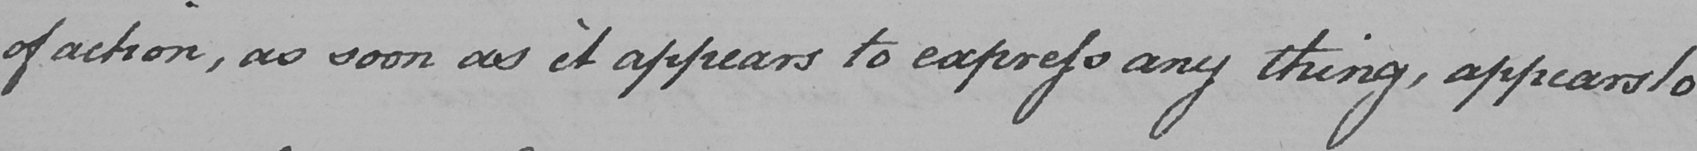Can you read and transcribe this handwriting? of action , as soon as it appears to express any thing , appears to 